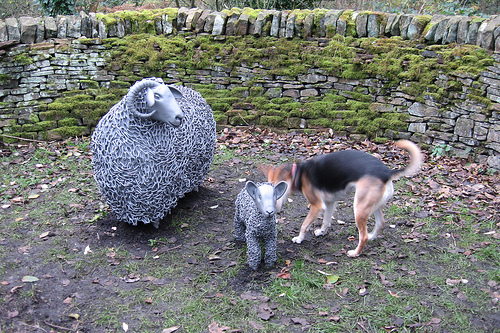<image>
Can you confirm if the momma sheep is next to the baby sheep? Yes. The momma sheep is positioned adjacent to the baby sheep, located nearby in the same general area. Where is the dog in relation to the wall? Is it on the wall? No. The dog is not positioned on the wall. They may be near each other, but the dog is not supported by or resting on top of the wall. Where is the statue in relation to the dog? Is it to the left of the dog? Yes. From this viewpoint, the statue is positioned to the left side relative to the dog. 